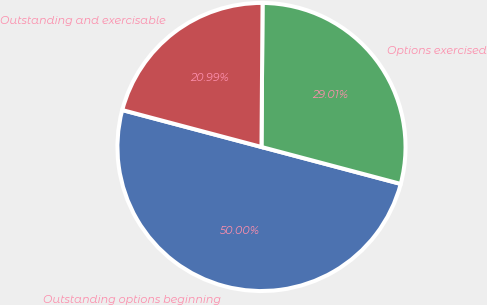Convert chart to OTSL. <chart><loc_0><loc_0><loc_500><loc_500><pie_chart><fcel>Outstanding options beginning<fcel>Options exercised<fcel>Outstanding and exercisable<nl><fcel>50.0%<fcel>29.01%<fcel>20.99%<nl></chart> 